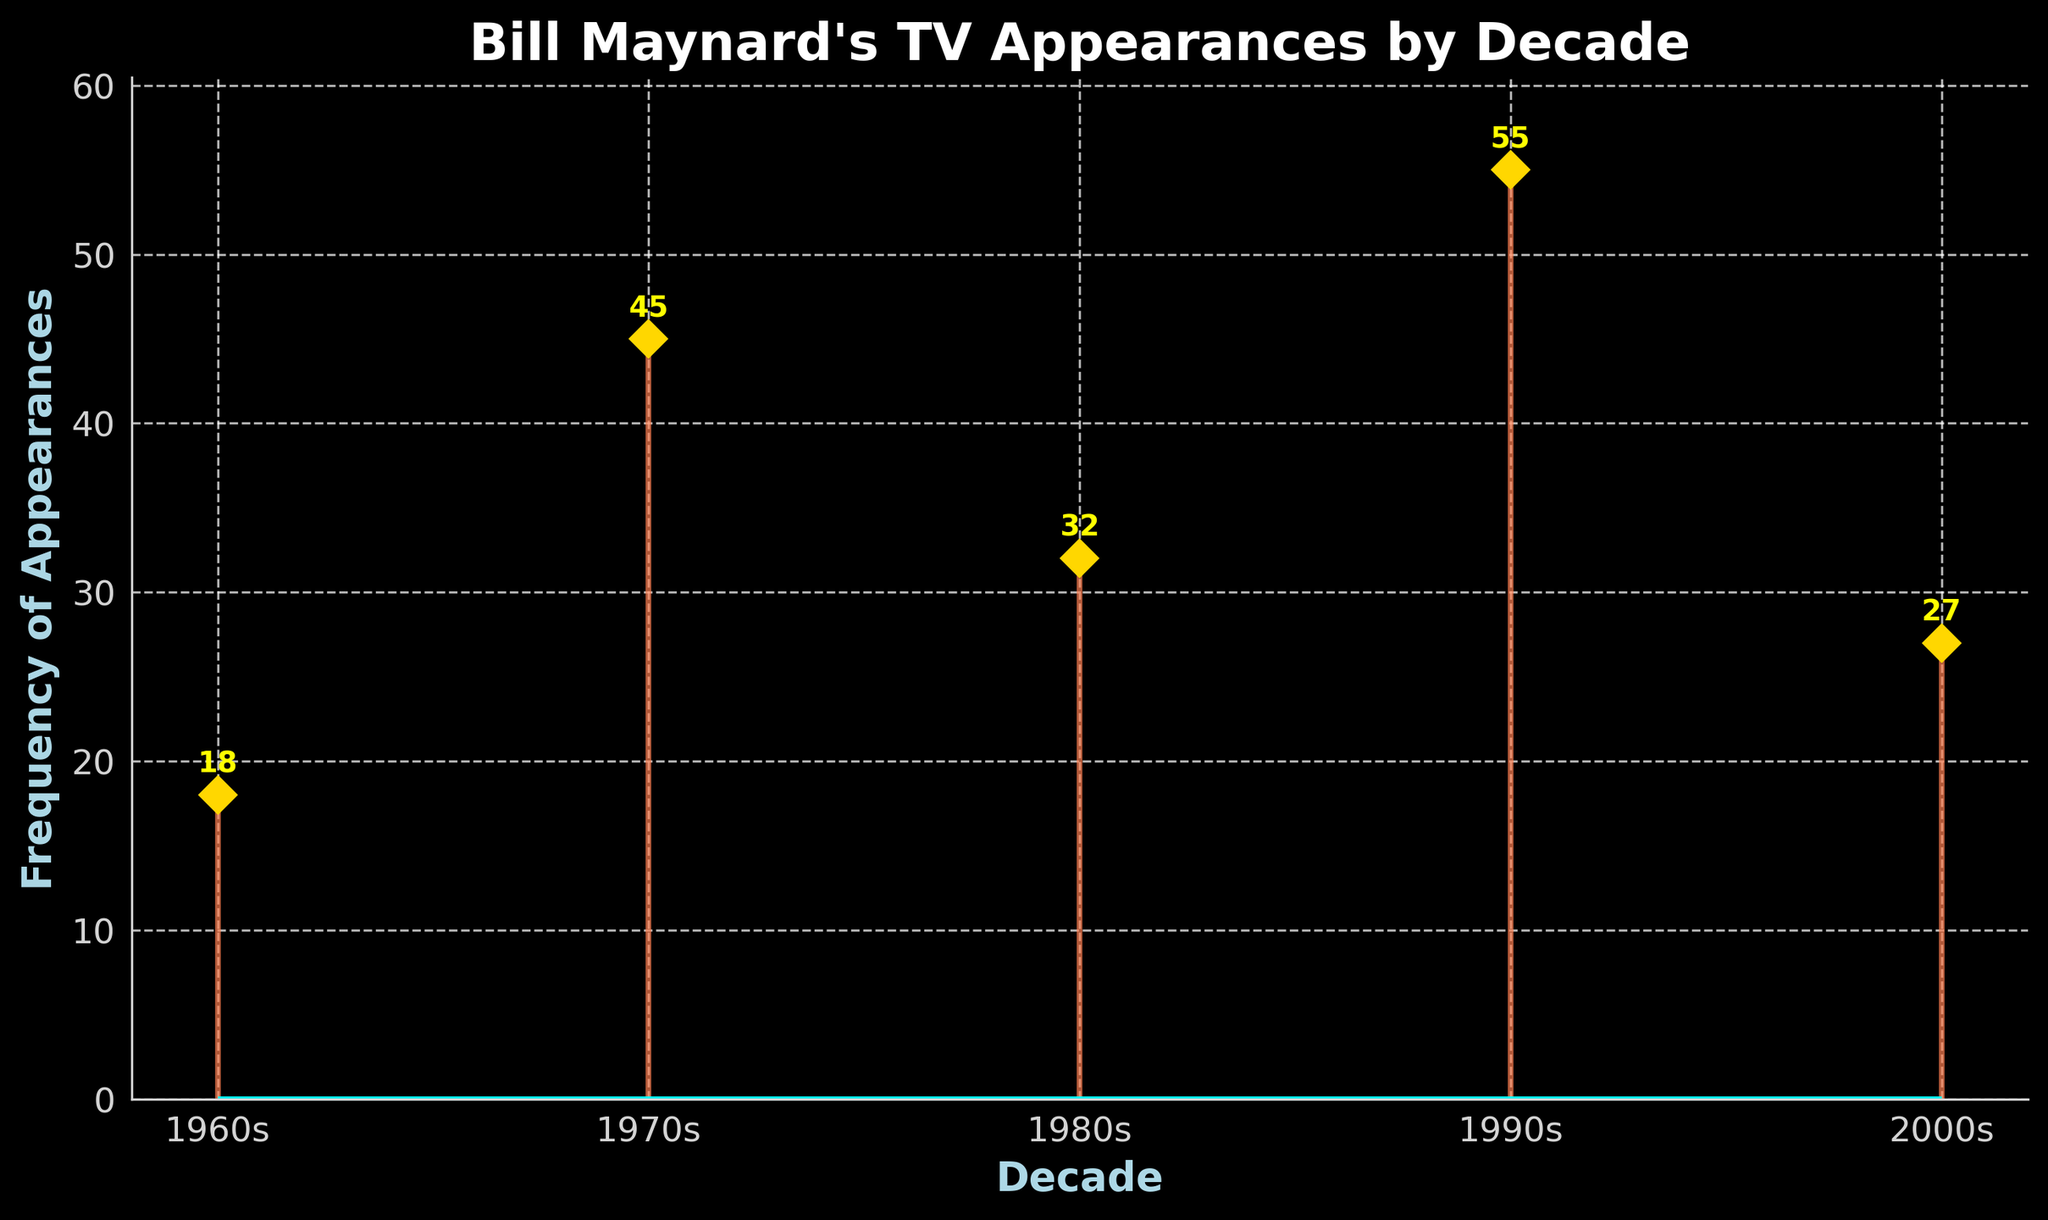What is the title of the plot? The title of the plot is written at the top of the figure in a large font. It clearly states what the plot is about.
Answer: Bill Maynard's TV Appearances by Decade What is the frequency of Bill Maynard's TV appearances in the 1990s? The frequency value for the 1990s is shown above the corresponding stem line on the plot.
Answer: 55 Which decade has the highest frequency of appearances? By comparing the height of the stems, the highest frequency is the one that reaches the topmost point. The number at the top of that stem line further confirms it.
Answer: 1990s How does the frequency in the 1980s compare to that in the 1970s? The frequency in the 1980s is represented by a stem smaller in height compared to the one in the 1970s. By referring to the values marked at the top, we see that 32 (1980s) is less than 45 (1970s).
Answer: Less What color represents the stems in the plot? The color of the stems can be identified by observing any one of the stem lines in the plot.
Answer: Coral What is the average frequency of appearances across all decades shown? To find the average, sum all the frequencies and divide by the number of decades. The sum is 18 + 45 + 32 + 55 + 27 = 177 and the number of decades is 5. So, 177 / 5 = 35.4
Answer: 35.4 How many years does each marker represent in the plot? The markers are plotted for each decade (10 years), and the title and x-axis labels confirm this time frame. As there are 5 data points and each is labeled by decade, it represents 10 years each.
Answer: 10 years What is the difference in frequency between the 1960s and the 2000s? Subtract the frequency in the 1960s from that in the 2000s: 27 - 18 = 9.
Answer: 9 Which decade shows a significant drop in the frequency of appearances compared to the previous one? By comparing the frequencies of consecutive decades and identifying where a significant decline occurs: the 2000s (27) compared to the 1990s (55) shows a significant drop.
Answer: 2000s What is the range of the frequencies displayed in the plot? The range is found by subtracting the smallest frequency (1960s: 18) from the largest frequency (1990s: 55). So, 55 - 18 = 37.
Answer: 37 